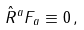Convert formula to latex. <formula><loc_0><loc_0><loc_500><loc_500>\hat { R } ^ { a } F _ { a } \equiv 0 \, ,</formula> 